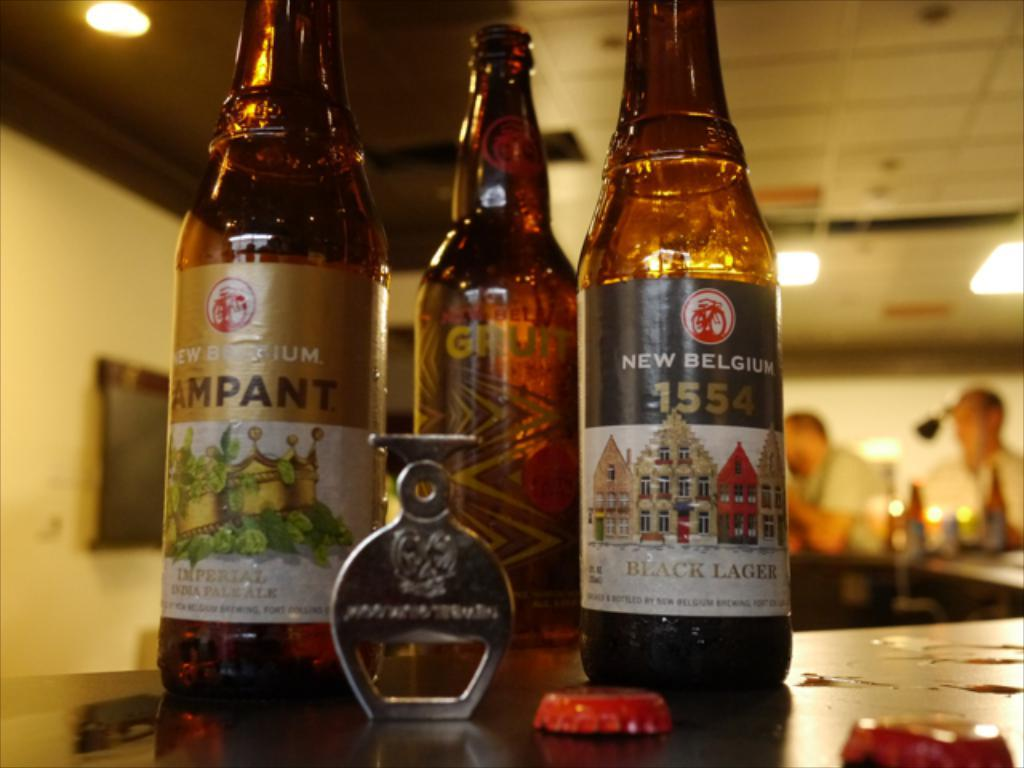<image>
Share a concise interpretation of the image provided. Three varieties of brown bottles of New Belgium Beer on a table. 